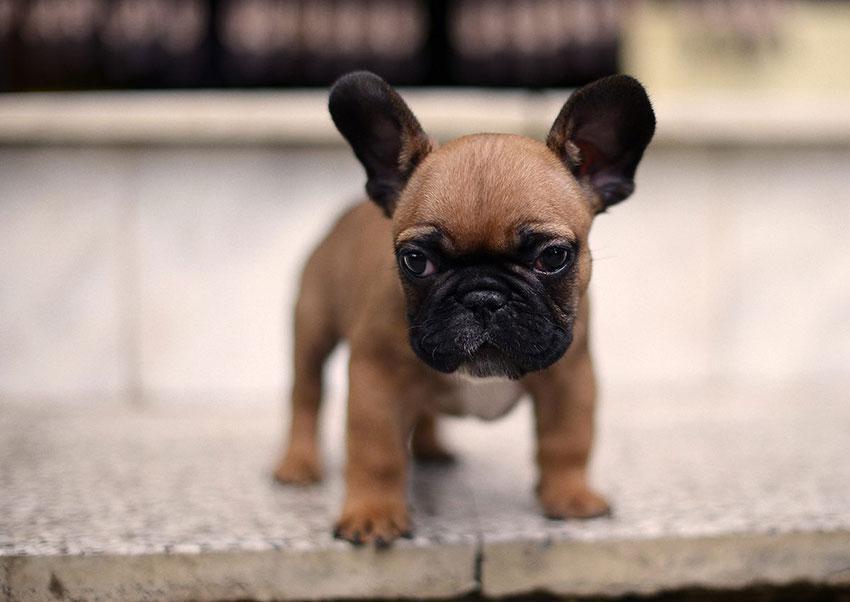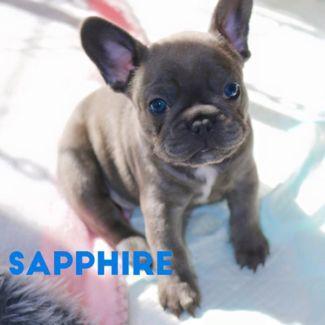The first image is the image on the left, the second image is the image on the right. Considering the images on both sides, is "A dog is wearing a collar." valid? Answer yes or no. No. The first image is the image on the left, the second image is the image on the right. Evaluate the accuracy of this statement regarding the images: "At least one dog is wearing a collar.". Is it true? Answer yes or no. No. 